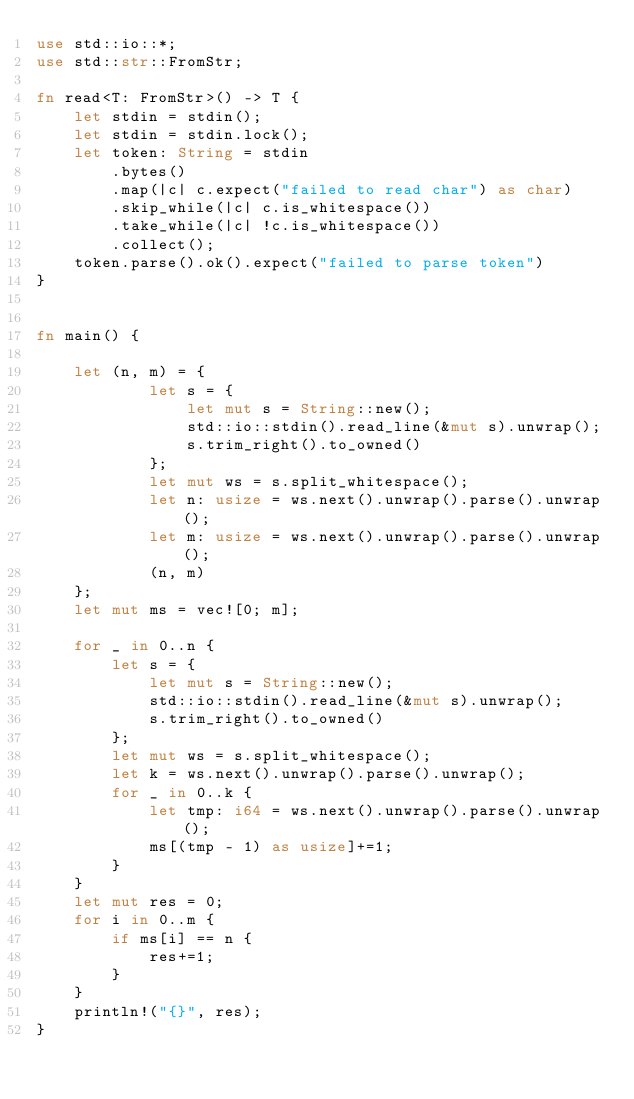Convert code to text. <code><loc_0><loc_0><loc_500><loc_500><_Rust_>use std::io::*;
use std::str::FromStr;

fn read<T: FromStr>() -> T {
    let stdin = stdin();
    let stdin = stdin.lock();
    let token: String = stdin
        .bytes()
        .map(|c| c.expect("failed to read char") as char)
        .skip_while(|c| c.is_whitespace())
        .take_while(|c| !c.is_whitespace())
        .collect();
    token.parse().ok().expect("failed to parse token")
}


fn main() {

    let (n, m) = {
            let s = {
                let mut s = String::new();
                std::io::stdin().read_line(&mut s).unwrap();
                s.trim_right().to_owned()
            };
            let mut ws = s.split_whitespace();
            let n: usize = ws.next().unwrap().parse().unwrap();
            let m: usize = ws.next().unwrap().parse().unwrap();
            (n, m)
    };
    let mut ms = vec![0; m];

    for _ in 0..n {
        let s = {
            let mut s = String::new();
            std::io::stdin().read_line(&mut s).unwrap();
            s.trim_right().to_owned()
        };
        let mut ws = s.split_whitespace();
        let k = ws.next().unwrap().parse().unwrap();
        for _ in 0..k {
            let tmp: i64 = ws.next().unwrap().parse().unwrap();
            ms[(tmp - 1) as usize]+=1;
        }
    }
    let mut res = 0;
    for i in 0..m {
        if ms[i] == n {
            res+=1;
        }
    }
    println!("{}", res);
}</code> 